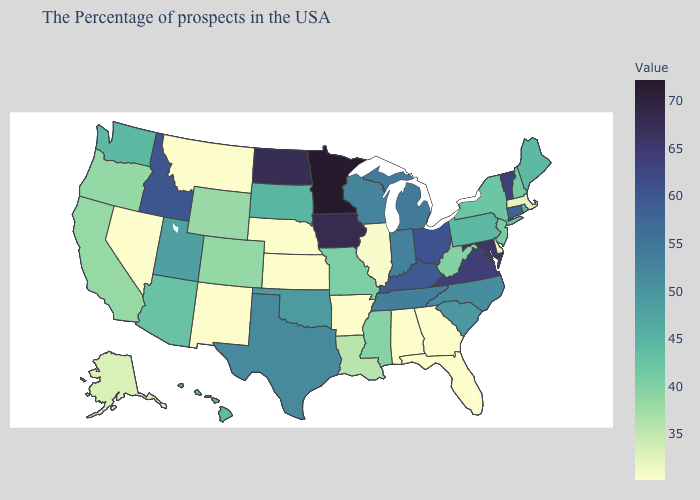Does Florida have a higher value than Ohio?
Keep it brief. No. Among the states that border Illinois , does Kentucky have the lowest value?
Keep it brief. No. Does Minnesota have the highest value in the USA?
Keep it brief. Yes. 